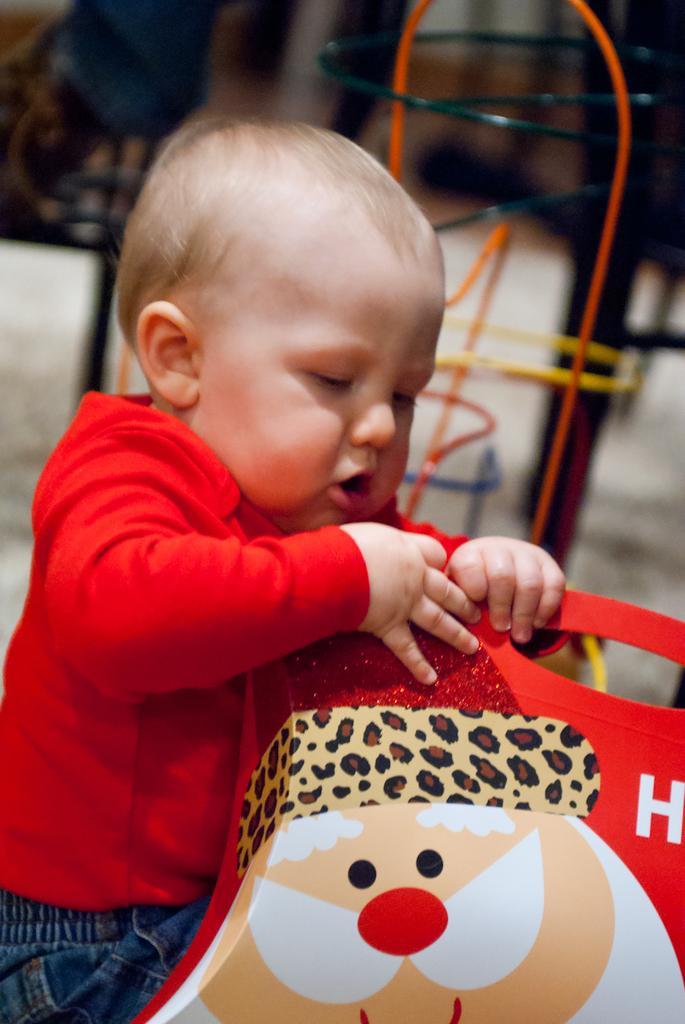Describe this image in one or two sentences. In the foreground of the picture there is a kid in red t-shirt, playing with a toy. The background is blurred. In the background there are some playing things. 